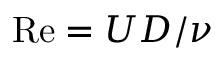<formula> <loc_0><loc_0><loc_500><loc_500>R e = U D / \nu</formula> 